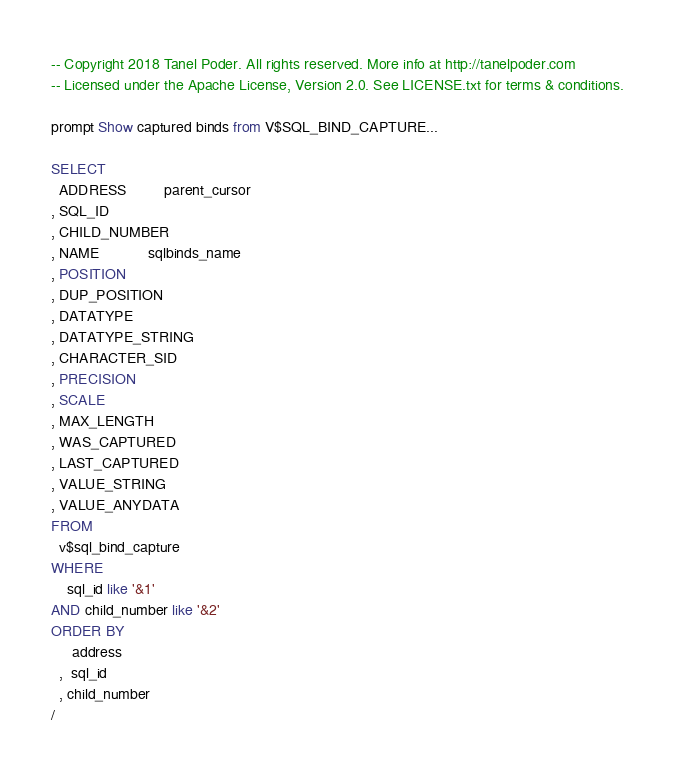Convert code to text. <code><loc_0><loc_0><loc_500><loc_500><_SQL_>-- Copyright 2018 Tanel Poder. All rights reserved. More info at http://tanelpoder.com
-- Licensed under the Apache License, Version 2.0. See LICENSE.txt for terms & conditions.

prompt Show captured binds from V$SQL_BIND_CAPTURE...

SELECT
  ADDRESS         parent_cursor
, SQL_ID              
, CHILD_NUMBER        
, NAME            sqlbinds_name              
, POSITION            
, DUP_POSITION        
, DATATYPE            
, DATATYPE_STRING     
, CHARACTER_SID       
, PRECISION           
, SCALE               
, MAX_LENGTH          
, WAS_CAPTURED        
, LAST_CAPTURED       
, VALUE_STRING        
, VALUE_ANYDATA  
FROM
  v$sql_bind_capture
WHERE
    sql_id like '&1'
AND child_number like '&2'
ORDER BY
     address
  ,  sql_id
  , child_number
/
</code> 